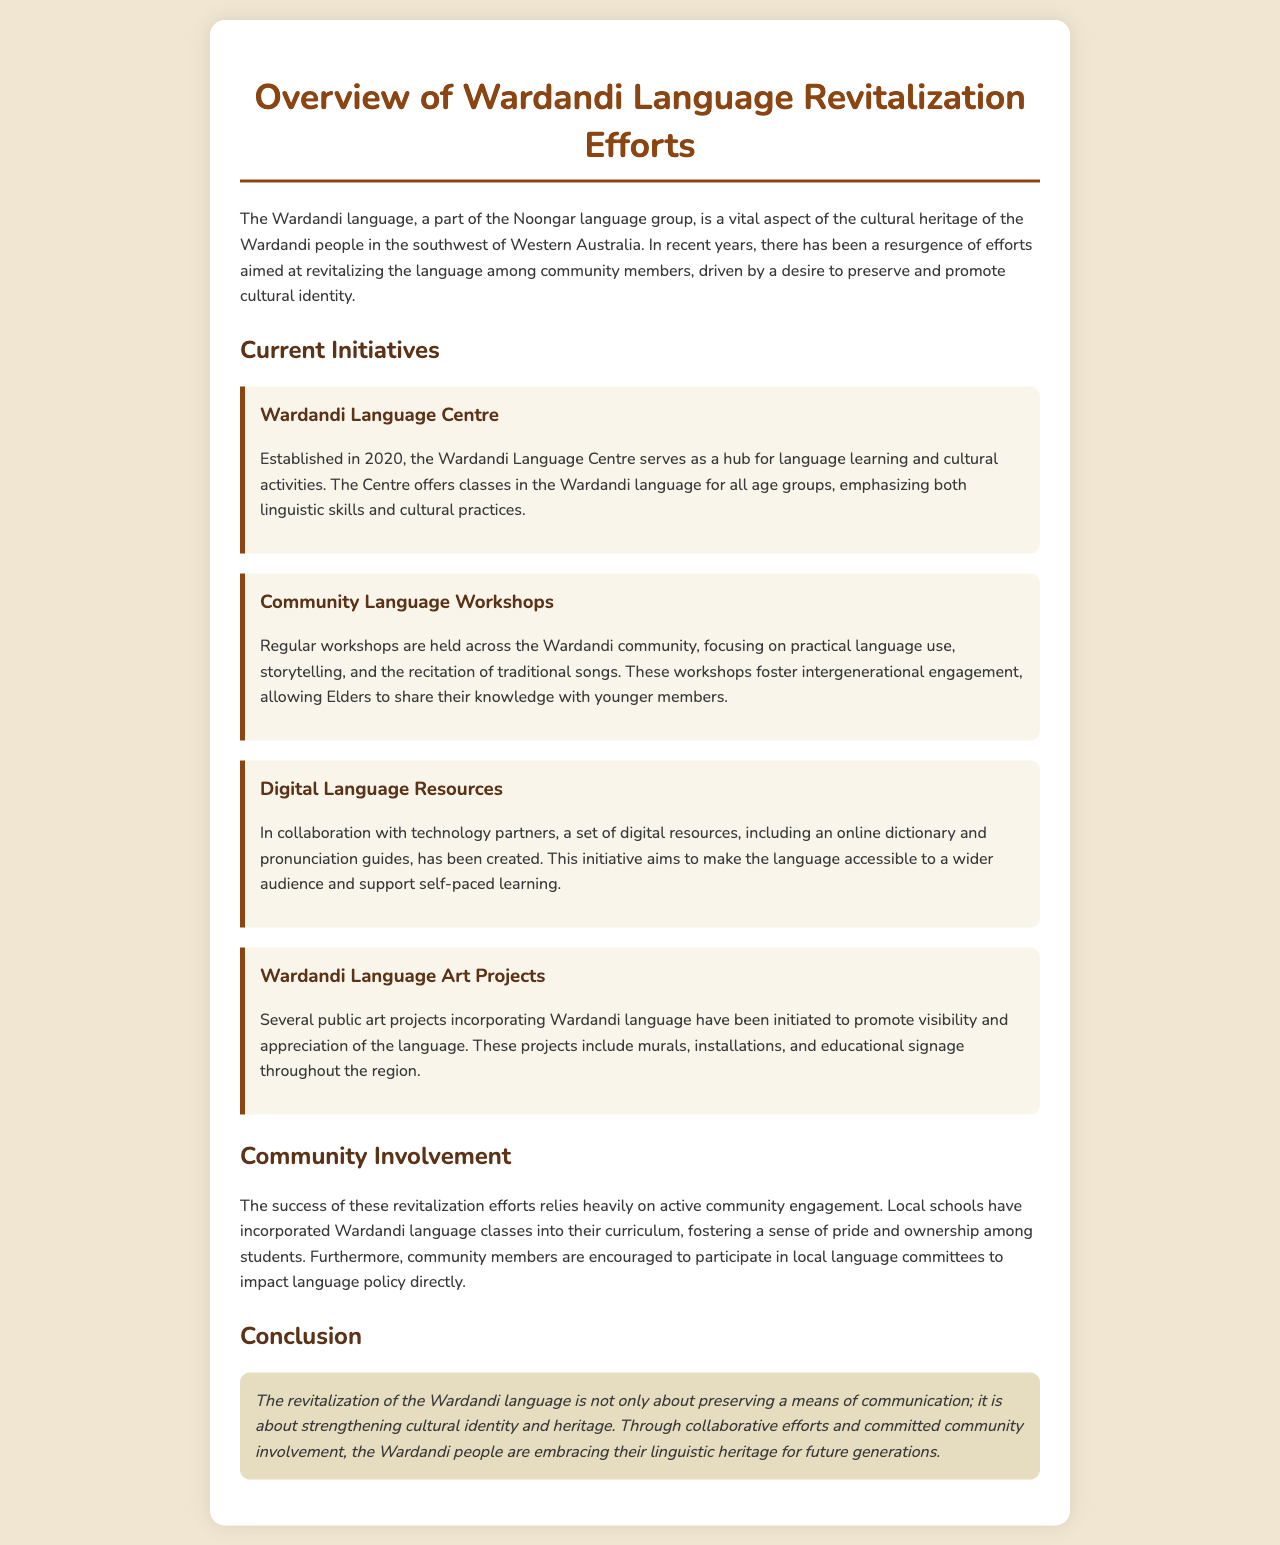What is the Wardandi language a part of? The Wardandi language is a part of the Noongar language group.
Answer: Noongar What year was the Wardandi Language Centre established? The Wardandi Language Centre was established in 2020.
Answer: 2020 What type of events do Community Language Workshops focus on? Community Language Workshops focus on practical language use, storytelling, and recitation of traditional songs.
Answer: Practical language use, storytelling, and recitation of traditional songs What resources were created in collaboration with technology partners? Digital resources, including an online dictionary and pronunciation guides, were created.
Answer: Online dictionary and pronunciation guides Who is encouraged to participate in local language committees? Community members are encouraged to participate in local language committees.
Answer: Community members What aspect of identity does the revitalization of the Wardandi language aim to strengthen? The revitalization aims to strengthen cultural identity and heritage.
Answer: Cultural identity and heritage How are local schools contributing to language revitalization? Local schools have incorporated Wardandi language classes into their curriculum.
Answer: Incorporating Wardandi language classes What is the primary goal of the Wardandi Language Art Projects? The primary goal is to promote visibility and appreciation of the language.
Answer: Promote visibility and appreciation of the language What role do Elders play in the Community Language Workshops? Elders share their knowledge with younger members during the workshops.
Answer: Share their knowledge with younger members 